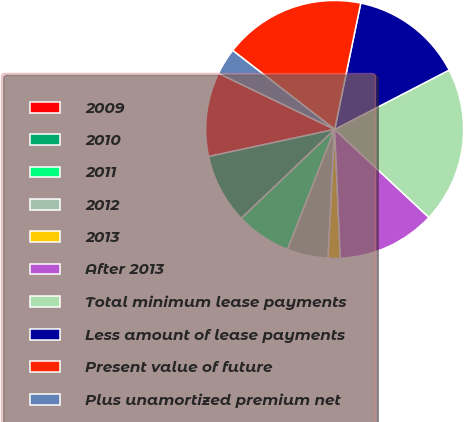Convert chart. <chart><loc_0><loc_0><loc_500><loc_500><pie_chart><fcel>2009<fcel>2010<fcel>2011<fcel>2012<fcel>2013<fcel>After 2013<fcel>Total minimum lease payments<fcel>Less amount of lease payments<fcel>Present value of future<fcel>Plus unamortized premium net<nl><fcel>10.54%<fcel>8.74%<fcel>6.93%<fcel>5.13%<fcel>1.52%<fcel>12.35%<fcel>19.56%<fcel>14.15%<fcel>17.76%<fcel>3.32%<nl></chart> 